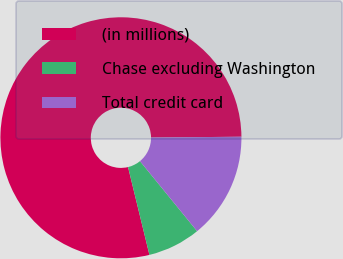Convert chart to OTSL. <chart><loc_0><loc_0><loc_500><loc_500><pie_chart><fcel>(in millions)<fcel>Chase excluding Washington<fcel>Total credit card<nl><fcel>78.67%<fcel>7.09%<fcel>14.25%<nl></chart> 